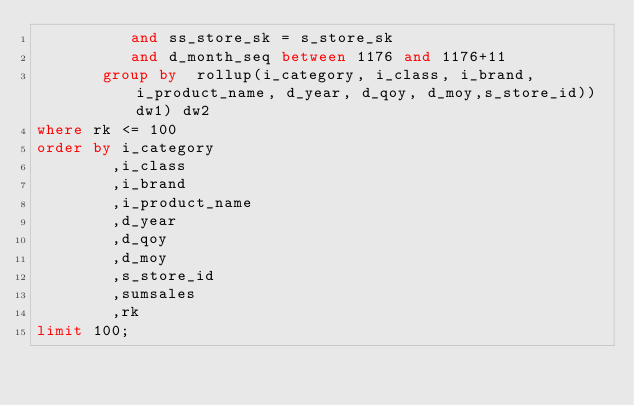Convert code to text. <code><loc_0><loc_0><loc_500><loc_500><_SQL_>          and ss_store_sk = s_store_sk
          and d_month_seq between 1176 and 1176+11
       group by  rollup(i_category, i_class, i_brand, i_product_name, d_year, d_qoy, d_moy,s_store_id))dw1) dw2
where rk <= 100
order by i_category
        ,i_class
        ,i_brand
        ,i_product_name
        ,d_year
        ,d_qoy
        ,d_moy
        ,s_store_id
        ,sumsales
        ,rk
limit 100;
</code> 